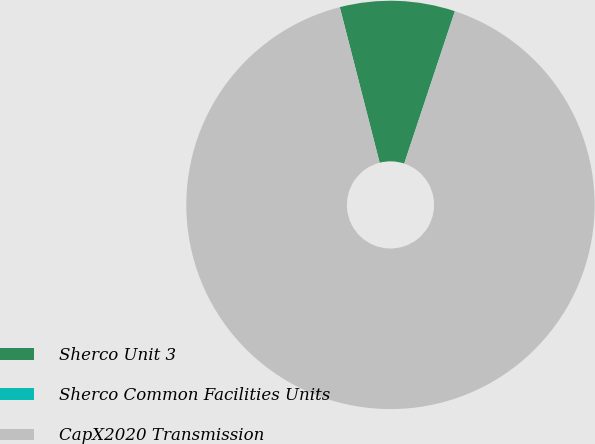Convert chart to OTSL. <chart><loc_0><loc_0><loc_500><loc_500><pie_chart><fcel>Sherco Unit 3<fcel>Sherco Common Facilities Units<fcel>CapX2020 Transmission<nl><fcel>9.1%<fcel>0.01%<fcel>90.89%<nl></chart> 